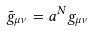Convert formula to latex. <formula><loc_0><loc_0><loc_500><loc_500>\bar { g } _ { \mu \nu } = a ^ { N } g _ { \mu \nu }</formula> 